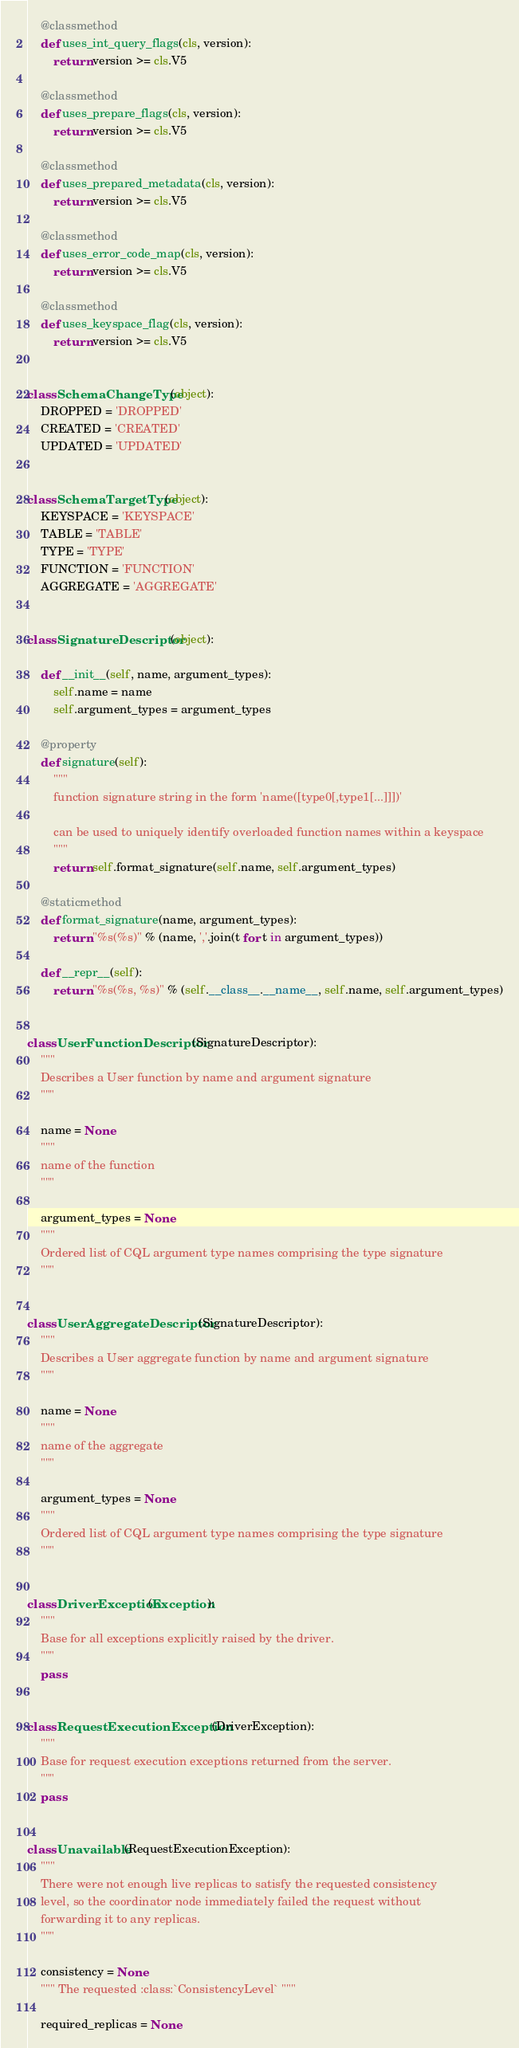<code> <loc_0><loc_0><loc_500><loc_500><_Python_>
    @classmethod
    def uses_int_query_flags(cls, version):
        return version >= cls.V5

    @classmethod
    def uses_prepare_flags(cls, version):
        return version >= cls.V5

    @classmethod
    def uses_prepared_metadata(cls, version):
        return version >= cls.V5

    @classmethod
    def uses_error_code_map(cls, version):
        return version >= cls.V5

    @classmethod
    def uses_keyspace_flag(cls, version):
        return version >= cls.V5


class SchemaChangeType(object):
    DROPPED = 'DROPPED'
    CREATED = 'CREATED'
    UPDATED = 'UPDATED'


class SchemaTargetType(object):
    KEYSPACE = 'KEYSPACE'
    TABLE = 'TABLE'
    TYPE = 'TYPE'
    FUNCTION = 'FUNCTION'
    AGGREGATE = 'AGGREGATE'


class SignatureDescriptor(object):

    def __init__(self, name, argument_types):
        self.name = name
        self.argument_types = argument_types

    @property
    def signature(self):
        """
        function signature string in the form 'name([type0[,type1[...]]])'

        can be used to uniquely identify overloaded function names within a keyspace
        """
        return self.format_signature(self.name, self.argument_types)

    @staticmethod
    def format_signature(name, argument_types):
        return "%s(%s)" % (name, ','.join(t for t in argument_types))

    def __repr__(self):
        return "%s(%s, %s)" % (self.__class__.__name__, self.name, self.argument_types)


class UserFunctionDescriptor(SignatureDescriptor):
    """
    Describes a User function by name and argument signature
    """

    name = None
    """
    name of the function
    """

    argument_types = None
    """
    Ordered list of CQL argument type names comprising the type signature
    """


class UserAggregateDescriptor(SignatureDescriptor):
    """
    Describes a User aggregate function by name and argument signature
    """

    name = None
    """
    name of the aggregate
    """

    argument_types = None
    """
    Ordered list of CQL argument type names comprising the type signature
    """


class DriverException(Exception):
    """
    Base for all exceptions explicitly raised by the driver.
    """
    pass


class RequestExecutionException(DriverException):
    """
    Base for request execution exceptions returned from the server.
    """
    pass


class Unavailable(RequestExecutionException):
    """
    There were not enough live replicas to satisfy the requested consistency
    level, so the coordinator node immediately failed the request without
    forwarding it to any replicas.
    """

    consistency = None
    """ The requested :class:`ConsistencyLevel` """

    required_replicas = None</code> 